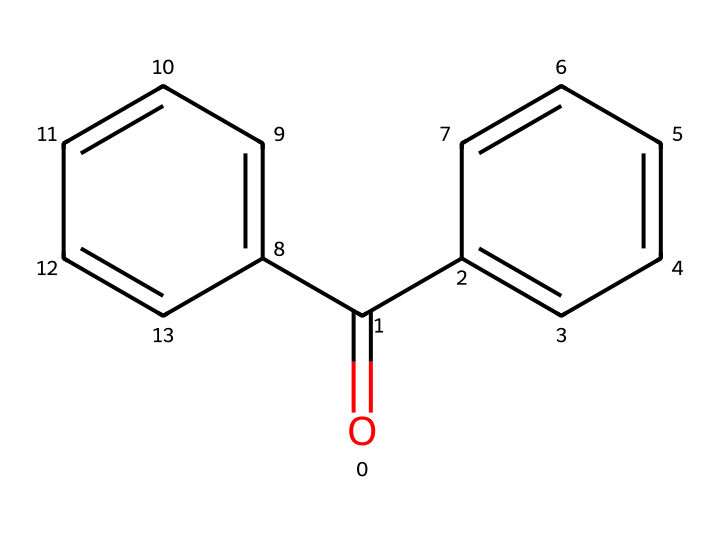What is the molecular formula of the compound represented by this SMILES? To derive the molecular formula, we can identify the atoms present in the structure. The structure contains two aromatic rings, which suggests a total of 12 carbon atoms (from the two benzene rings) plus one carbon from the carbonyl group, yielding 13 carbon atoms. Additionally, there is one oxygen from the carbonyl group. Thus, the molecular formula is C13H10O.
Answer: C13H10O How many aromatic rings are present in this molecule? By examining the structure, we can see that there are two distinct planar arrangements of carbon atoms that form the rings, indicating the presence of two aromatic rings in the compound.
Answer: 2 What functional group is present in this chemical structure? The molecule includes a carbonyl group (C=O), which is clearly visible attached to one of the benzene rings. This identifies it as an aromatic ketone due to the carbonyl being bonded to two carbon atoms from aromatic rings.
Answer: carbonyl group What is the total number of double bonds in the structure? Looking closely, we can identify the two double bonds present in the carbonyl group and an additional six double bonds in the aromatic rings, resulting in a total of eight double bonds in this structure.
Answer: 8 What type of photoinitiators could this compound be associated with? Given that this compound has two aromatic groups and a carbonyl, it is likely to function as a type of UV photoinitiator due to its ability to absorb UV light and produce free radicals for polymerization processes.
Answer: UV photoinitiator What is the significance of the carbonyl group in this compound concerning light absorption? The carbonyl group in the structure has a significant role in light absorption because it can undergo electronic transitions when exposed to UV light, leading to the initiation of the curing process, which is critical in forming durable coatings.
Answer: initiates curing process 